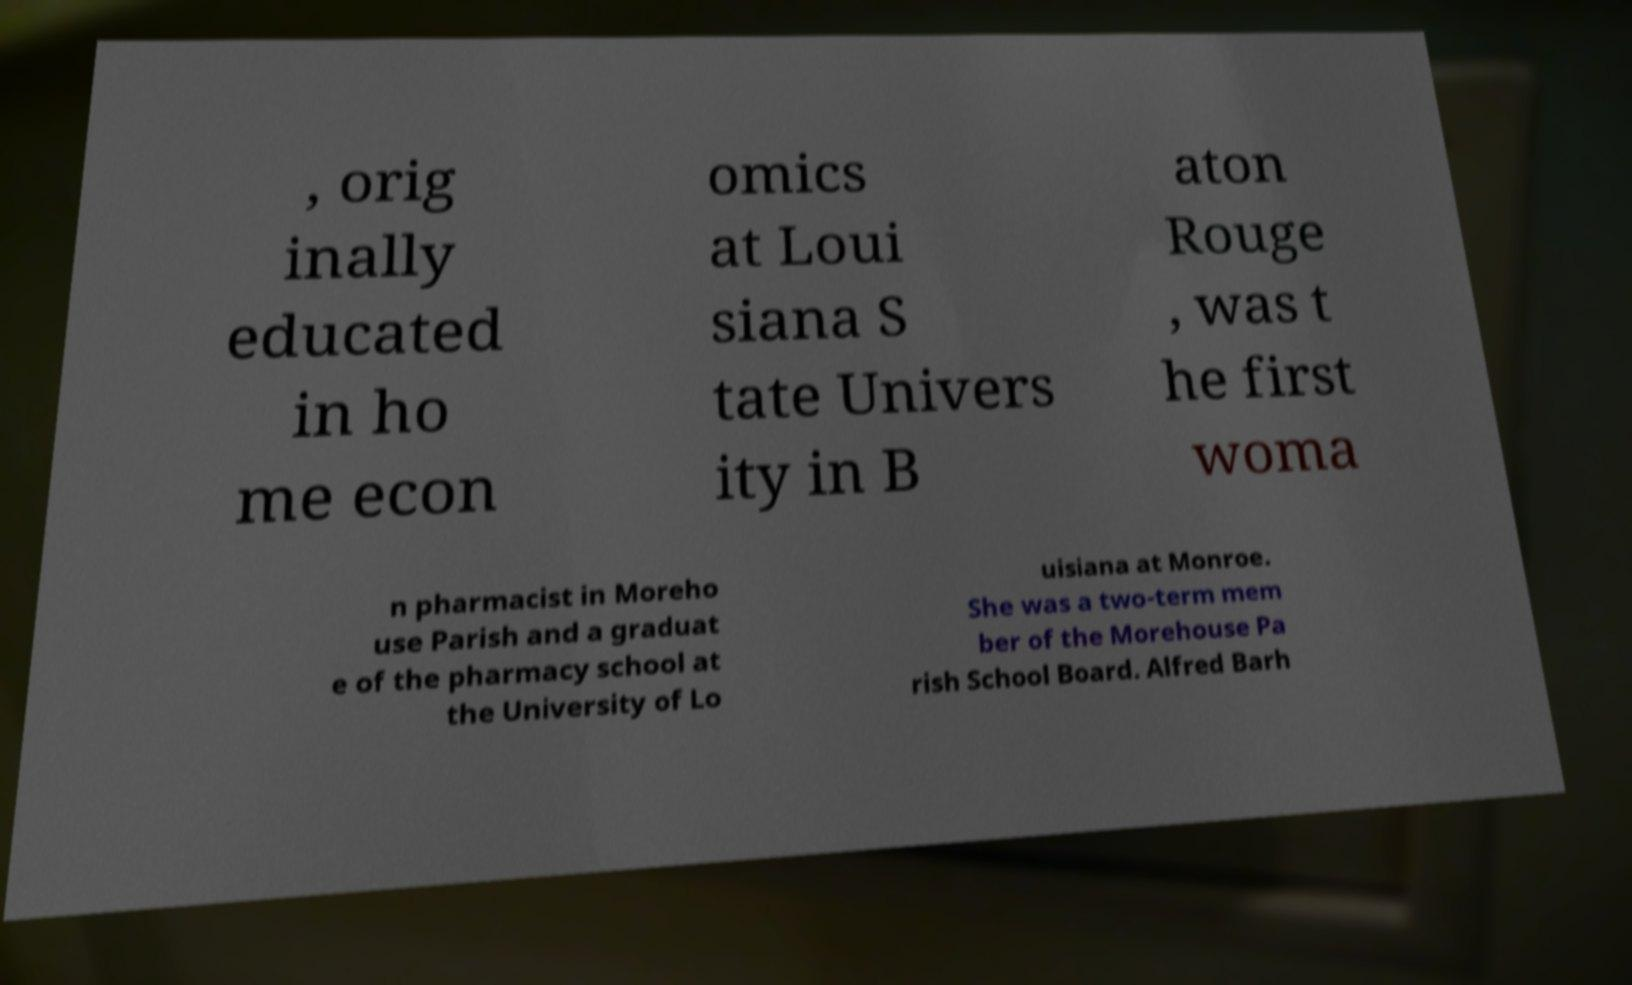Please read and relay the text visible in this image. What does it say? , orig inally educated in ho me econ omics at Loui siana S tate Univers ity in B aton Rouge , was t he first woma n pharmacist in Moreho use Parish and a graduat e of the pharmacy school at the University of Lo uisiana at Monroe. She was a two-term mem ber of the Morehouse Pa rish School Board. Alfred Barh 